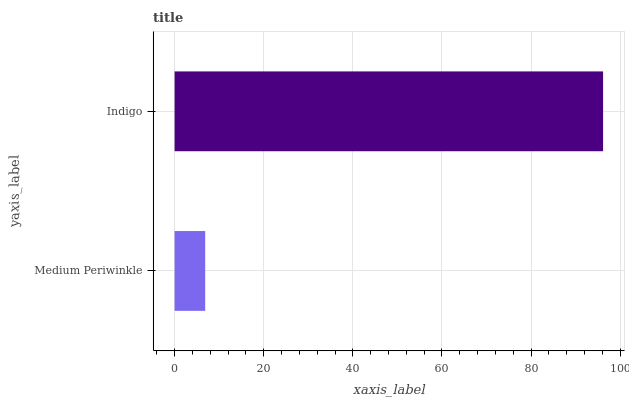Is Medium Periwinkle the minimum?
Answer yes or no. Yes. Is Indigo the maximum?
Answer yes or no. Yes. Is Indigo the minimum?
Answer yes or no. No. Is Indigo greater than Medium Periwinkle?
Answer yes or no. Yes. Is Medium Periwinkle less than Indigo?
Answer yes or no. Yes. Is Medium Periwinkle greater than Indigo?
Answer yes or no. No. Is Indigo less than Medium Periwinkle?
Answer yes or no. No. Is Indigo the high median?
Answer yes or no. Yes. Is Medium Periwinkle the low median?
Answer yes or no. Yes. Is Medium Periwinkle the high median?
Answer yes or no. No. Is Indigo the low median?
Answer yes or no. No. 